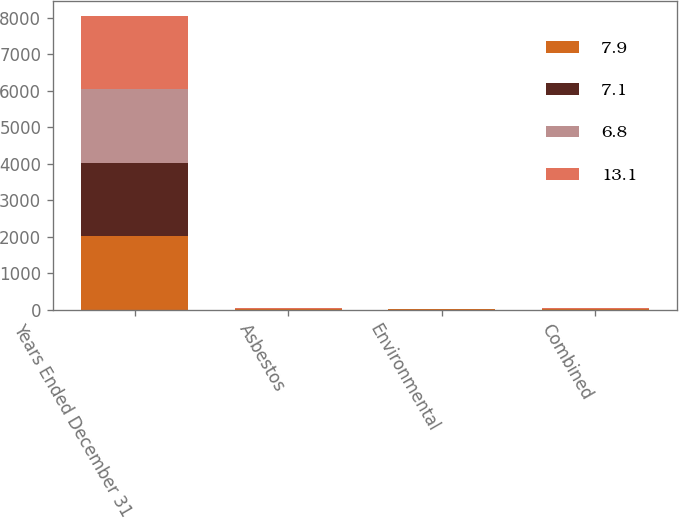<chart> <loc_0><loc_0><loc_500><loc_500><stacked_bar_chart><ecel><fcel>Years Ended December 31<fcel>Asbestos<fcel>Environmental<fcel>Combined<nl><fcel>7.9<fcel>2015<fcel>6.6<fcel>7.6<fcel>6.8<nl><fcel>7.1<fcel>2015<fcel>15<fcel>6.4<fcel>13.1<nl><fcel>6.8<fcel>2014<fcel>8.3<fcel>5<fcel>7.9<nl><fcel>13.1<fcel>2014<fcel>7.6<fcel>4.3<fcel>7.1<nl></chart> 